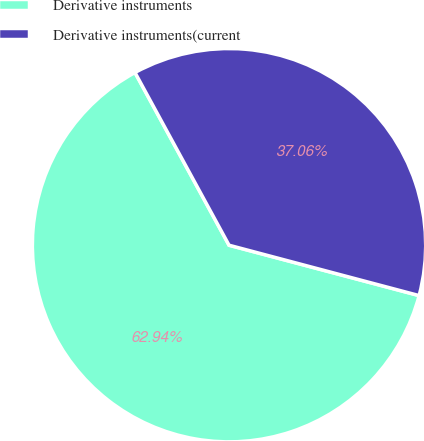Convert chart to OTSL. <chart><loc_0><loc_0><loc_500><loc_500><pie_chart><fcel>Derivative instruments<fcel>Derivative instruments(current<nl><fcel>62.94%<fcel>37.06%<nl></chart> 